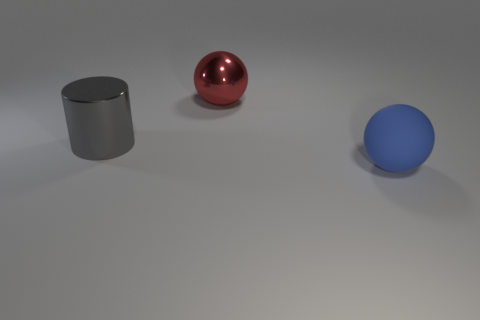Are there any big blue rubber things on the left side of the sphere to the right of the ball left of the big rubber thing?
Give a very brief answer. No. What number of gray shiny objects are to the left of the red shiny thing?
Your answer should be compact. 1. How many tiny things are red balls or gray shiny cylinders?
Provide a short and direct response. 0. What is the shape of the large object in front of the gray metallic object?
Your response must be concise. Sphere. Are there any shiny objects that have the same color as the large cylinder?
Make the answer very short. No. Is the size of the thing that is behind the large gray cylinder the same as the object in front of the gray thing?
Provide a succinct answer. Yes. Are there more large objects that are on the left side of the blue ball than balls in front of the large red ball?
Ensure brevity in your answer.  Yes. Are there any big green things that have the same material as the red object?
Provide a short and direct response. No. Is the color of the matte sphere the same as the metal ball?
Offer a very short reply. No. There is a object that is both on the left side of the large matte thing and in front of the red metallic thing; what is its material?
Make the answer very short. Metal. 